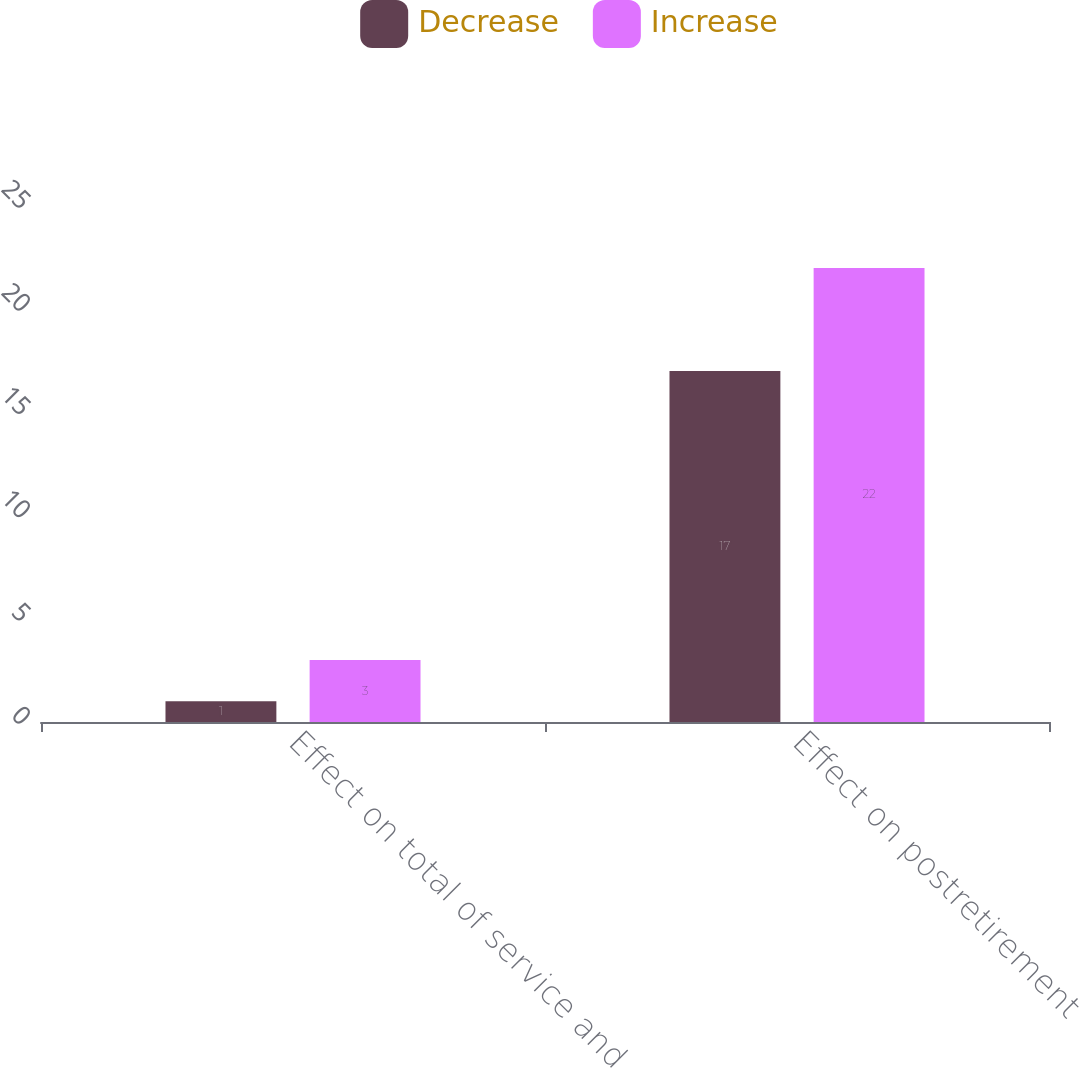Convert chart to OTSL. <chart><loc_0><loc_0><loc_500><loc_500><stacked_bar_chart><ecel><fcel>Effect on total of service and<fcel>Effect on postretirement<nl><fcel>Decrease<fcel>1<fcel>17<nl><fcel>Increase<fcel>3<fcel>22<nl></chart> 